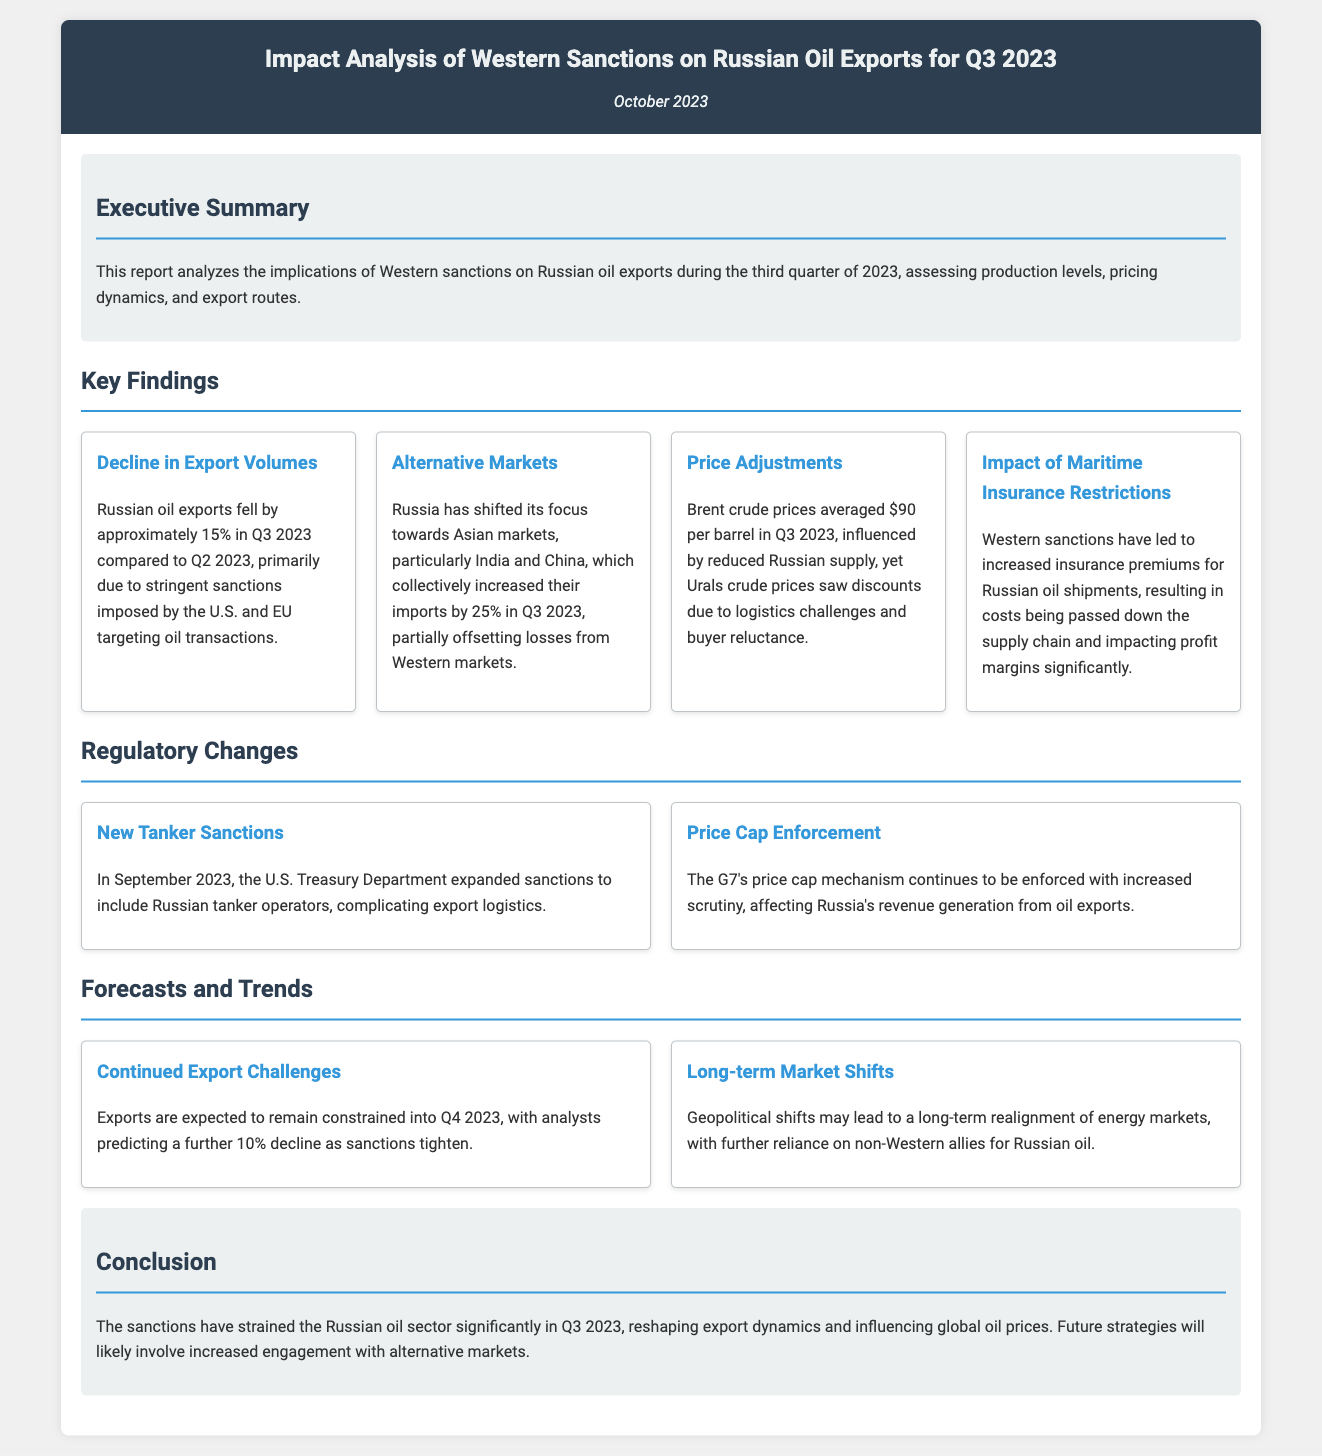what was the percentage decline in Russian oil exports in Q3 2023? The document states that Russian oil exports fell by approximately 15% in Q3 2023 compared to Q2 2023.
Answer: 15% which countries increased their oil imports from Russia in Q3 2023? The report highlights that India and China collectively increased their imports by 25% in Q3 2023.
Answer: India and China what was the average price of Brent crude in Q3 2023? According to the report, Brent crude prices averaged $90 per barrel in Q3 2023.
Answer: $90 what are the two main regulatory changes mentioned in the document? The document refers to "New Tanker Sanctions" and "Price Cap Enforcement" as the two main regulatory changes.
Answer: New Tanker Sanctions and Price Cap Enforcement what is the predicted percentage decline in exports for Q4 2023? The report indicates analysts predict a further 10% decline in exports for Q4 2023.
Answer: 10% how did Western sanctions affect maritime insurance costs for Russian oil shipments? The document states that Western sanctions led to increased insurance premiums for Russian oil shipments.
Answer: Increased insurance premiums what significant factor influenced Urals crude prices in Q3 2023? The document attributes the discounts in Urals crude prices to logistics challenges and buyer reluctance.
Answer: Logistics challenges and buyer reluctance what was the primary reason for the decline in Russian oil exports? The report attributes the decline to stringent sanctions imposed by the U.S. and EU targeting oil transactions.
Answer: Stringent sanctions what is the conclusion of the report regarding the future strategies of Russia's oil sector? The conclusion states that future strategies will likely involve increased engagement with alternative markets.
Answer: Increased engagement with alternative markets 